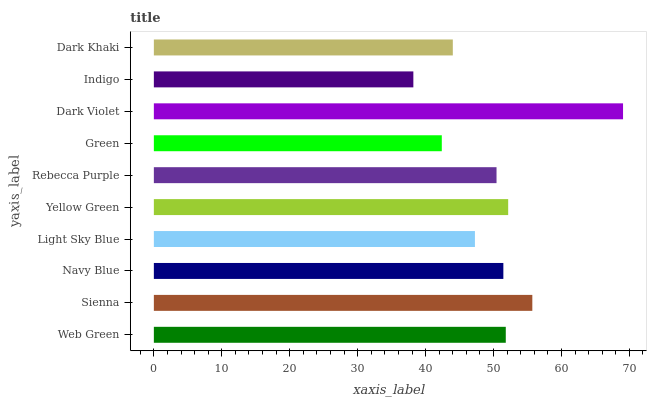Is Indigo the minimum?
Answer yes or no. Yes. Is Dark Violet the maximum?
Answer yes or no. Yes. Is Sienna the minimum?
Answer yes or no. No. Is Sienna the maximum?
Answer yes or no. No. Is Sienna greater than Web Green?
Answer yes or no. Yes. Is Web Green less than Sienna?
Answer yes or no. Yes. Is Web Green greater than Sienna?
Answer yes or no. No. Is Sienna less than Web Green?
Answer yes or no. No. Is Navy Blue the high median?
Answer yes or no. Yes. Is Rebecca Purple the low median?
Answer yes or no. Yes. Is Sienna the high median?
Answer yes or no. No. Is Dark Violet the low median?
Answer yes or no. No. 